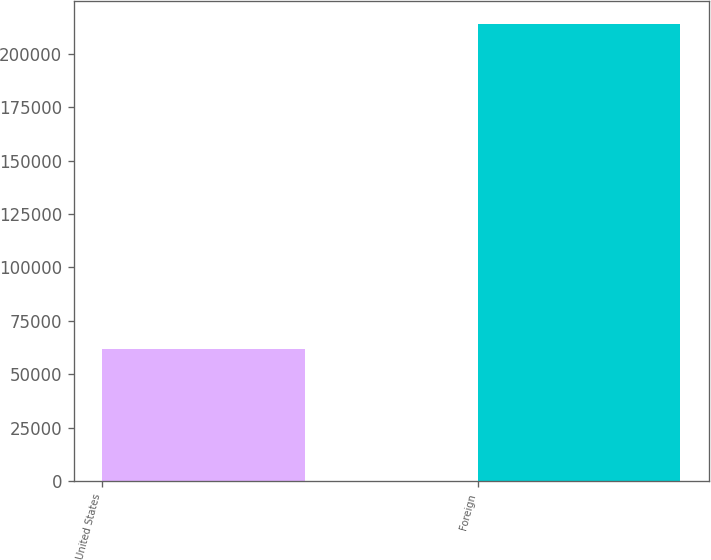Convert chart. <chart><loc_0><loc_0><loc_500><loc_500><bar_chart><fcel>United States<fcel>Foreign<nl><fcel>61818<fcel>213848<nl></chart> 